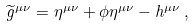Convert formula to latex. <formula><loc_0><loc_0><loc_500><loc_500>\widetilde { g } ^ { \mu \nu } = \eta ^ { \mu \nu } + \phi \eta ^ { \mu \nu } - h ^ { \mu \nu } \, ,</formula> 